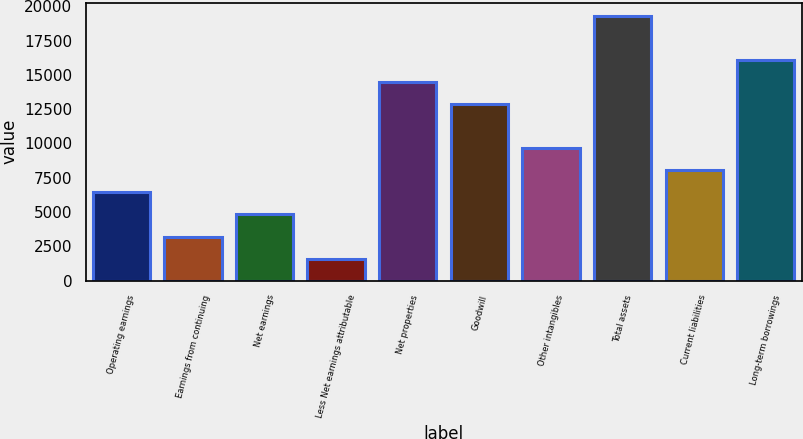Convert chart. <chart><loc_0><loc_0><loc_500><loc_500><bar_chart><fcel>Operating earnings<fcel>Earnings from continuing<fcel>Net earnings<fcel>Less Net earnings attributable<fcel>Net properties<fcel>Goodwill<fcel>Other intangibles<fcel>Total assets<fcel>Current liabilities<fcel>Long-term borrowings<nl><fcel>6429.68<fcel>3215.57<fcel>4822.62<fcel>1608.51<fcel>14465<fcel>12857.9<fcel>9643.8<fcel>19286.1<fcel>8036.74<fcel>16072<nl></chart> 